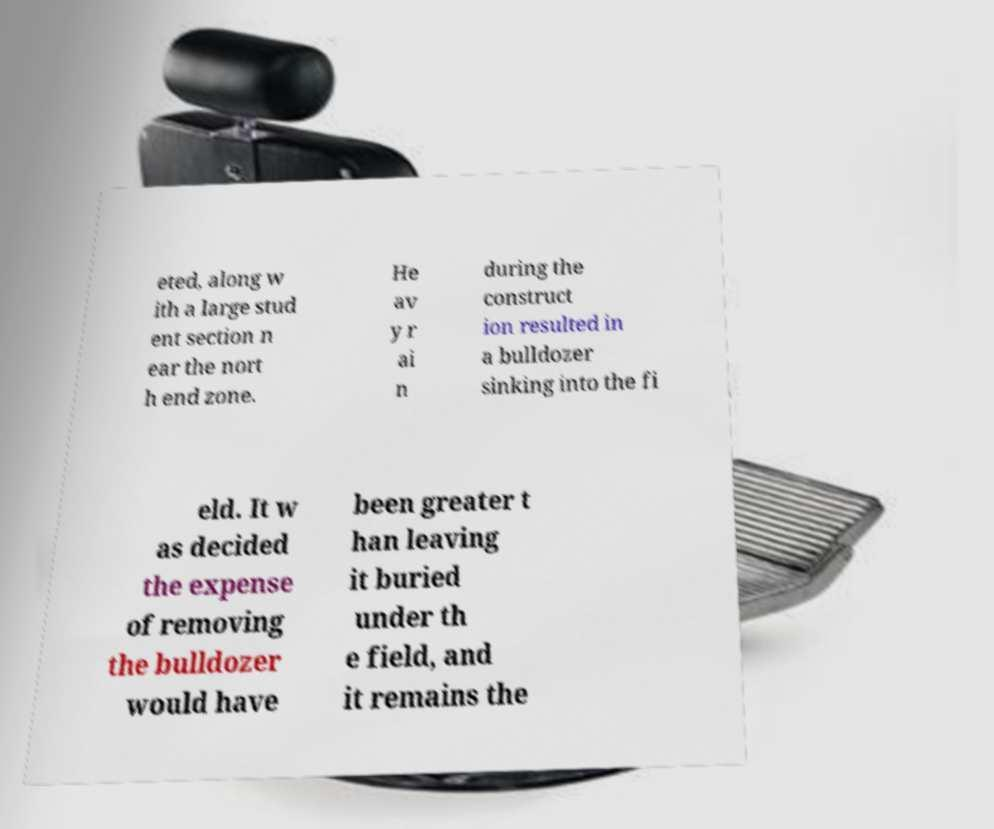Could you assist in decoding the text presented in this image and type it out clearly? eted, along w ith a large stud ent section n ear the nort h end zone. He av y r ai n during the construct ion resulted in a bulldozer sinking into the fi eld. It w as decided the expense of removing the bulldozer would have been greater t han leaving it buried under th e field, and it remains the 